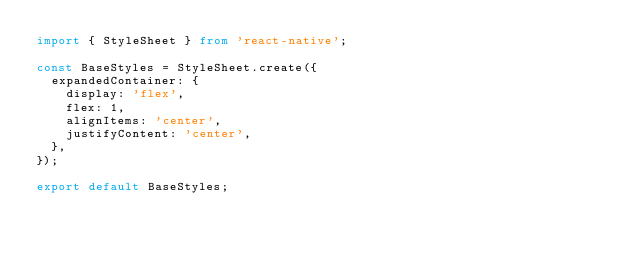<code> <loc_0><loc_0><loc_500><loc_500><_TypeScript_>import { StyleSheet } from 'react-native';

const BaseStyles = StyleSheet.create({
  expandedContainer: {
    display: 'flex',
    flex: 1,
    alignItems: 'center',
    justifyContent: 'center',
  },
});

export default BaseStyles;
</code> 